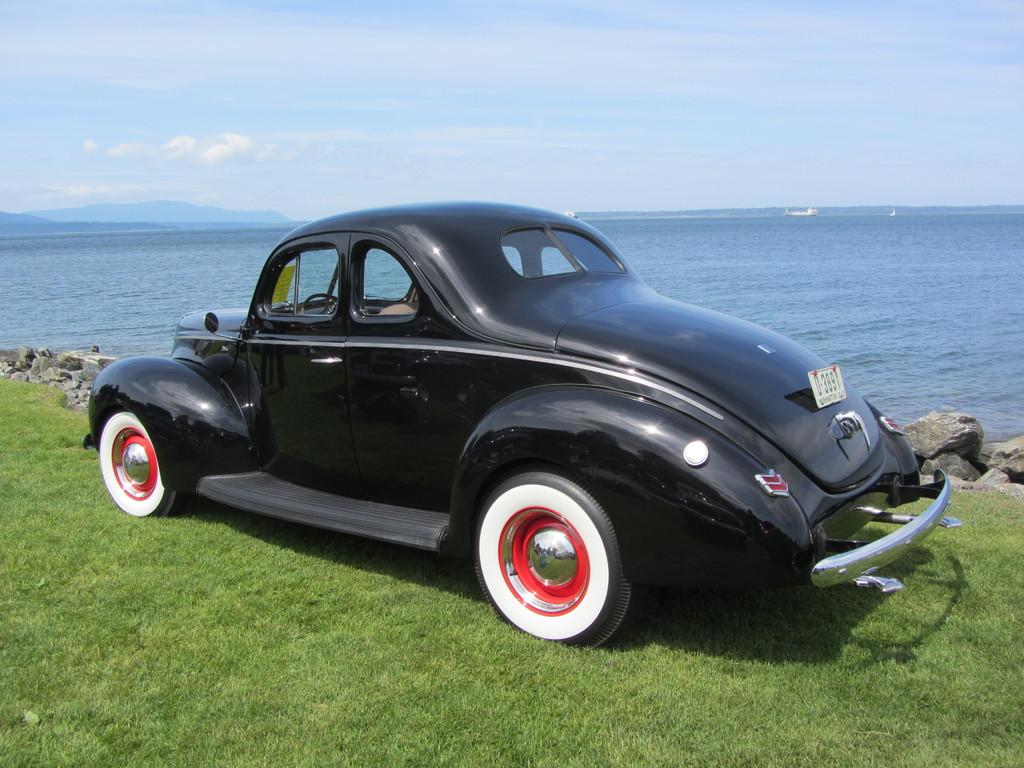What type of vehicle is in the image? There is a black car in the image. Where is the car located? The car is parked on the grass. What can be seen in the background of the image? There are stones, water, mountains, and the sky visible in the background of the image. How does the car hook onto the island in the image? There is no island or hook present in the image; the car is parked on the grass, and the background features stones, water, mountains, and the sky. 